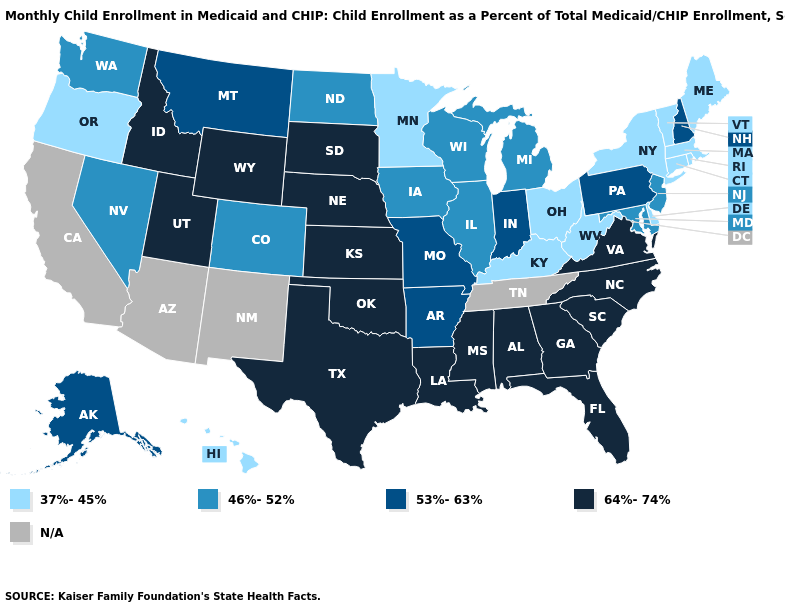Does the first symbol in the legend represent the smallest category?
Answer briefly. Yes. What is the value of West Virginia?
Keep it brief. 37%-45%. What is the value of Louisiana?
Write a very short answer. 64%-74%. What is the lowest value in the USA?
Concise answer only. 37%-45%. What is the value of South Dakota?
Short answer required. 64%-74%. Name the states that have a value in the range 46%-52%?
Be succinct. Colorado, Illinois, Iowa, Maryland, Michigan, Nevada, New Jersey, North Dakota, Washington, Wisconsin. What is the value of Florida?
Answer briefly. 64%-74%. How many symbols are there in the legend?
Keep it brief. 5. Does the map have missing data?
Keep it brief. Yes. What is the value of Texas?
Concise answer only. 64%-74%. Among the states that border New York , which have the lowest value?
Quick response, please. Connecticut, Massachusetts, Vermont. Does Georgia have the lowest value in the USA?
Be succinct. No. 